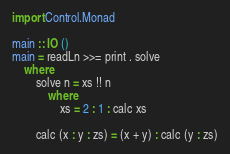<code> <loc_0><loc_0><loc_500><loc_500><_Haskell_>import Control.Monad 

main :: IO ()
main = readLn >>= print . solve 
    where
        solve n = xs !! n
            where
                xs = 2 : 1 : calc xs

        calc (x : y : zs) = (x + y) : calc (y : zs)
</code> 